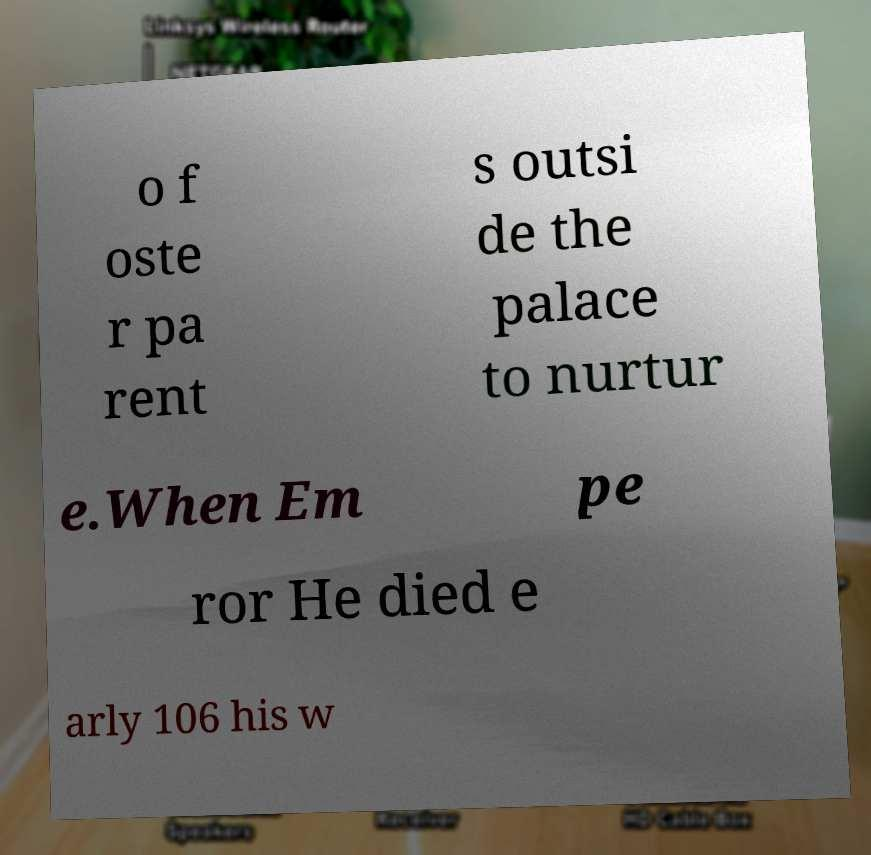Can you read and provide the text displayed in the image?This photo seems to have some interesting text. Can you extract and type it out for me? o f oste r pa rent s outsi de the palace to nurtur e.When Em pe ror He died e arly 106 his w 